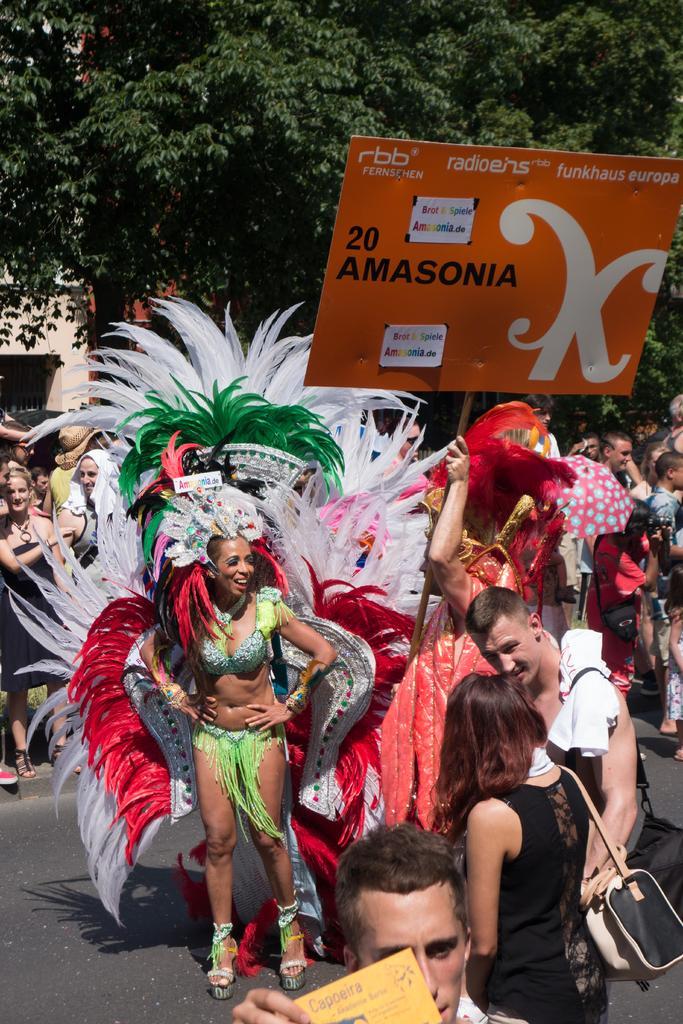Can you describe this image briefly? In this image we can see a man and a woman wearing the costumes standing on the ground. In that a man is holding a board with some text on it. We can also see a group of people, a tree and a building. In the foreground we can see a man holding a card. 